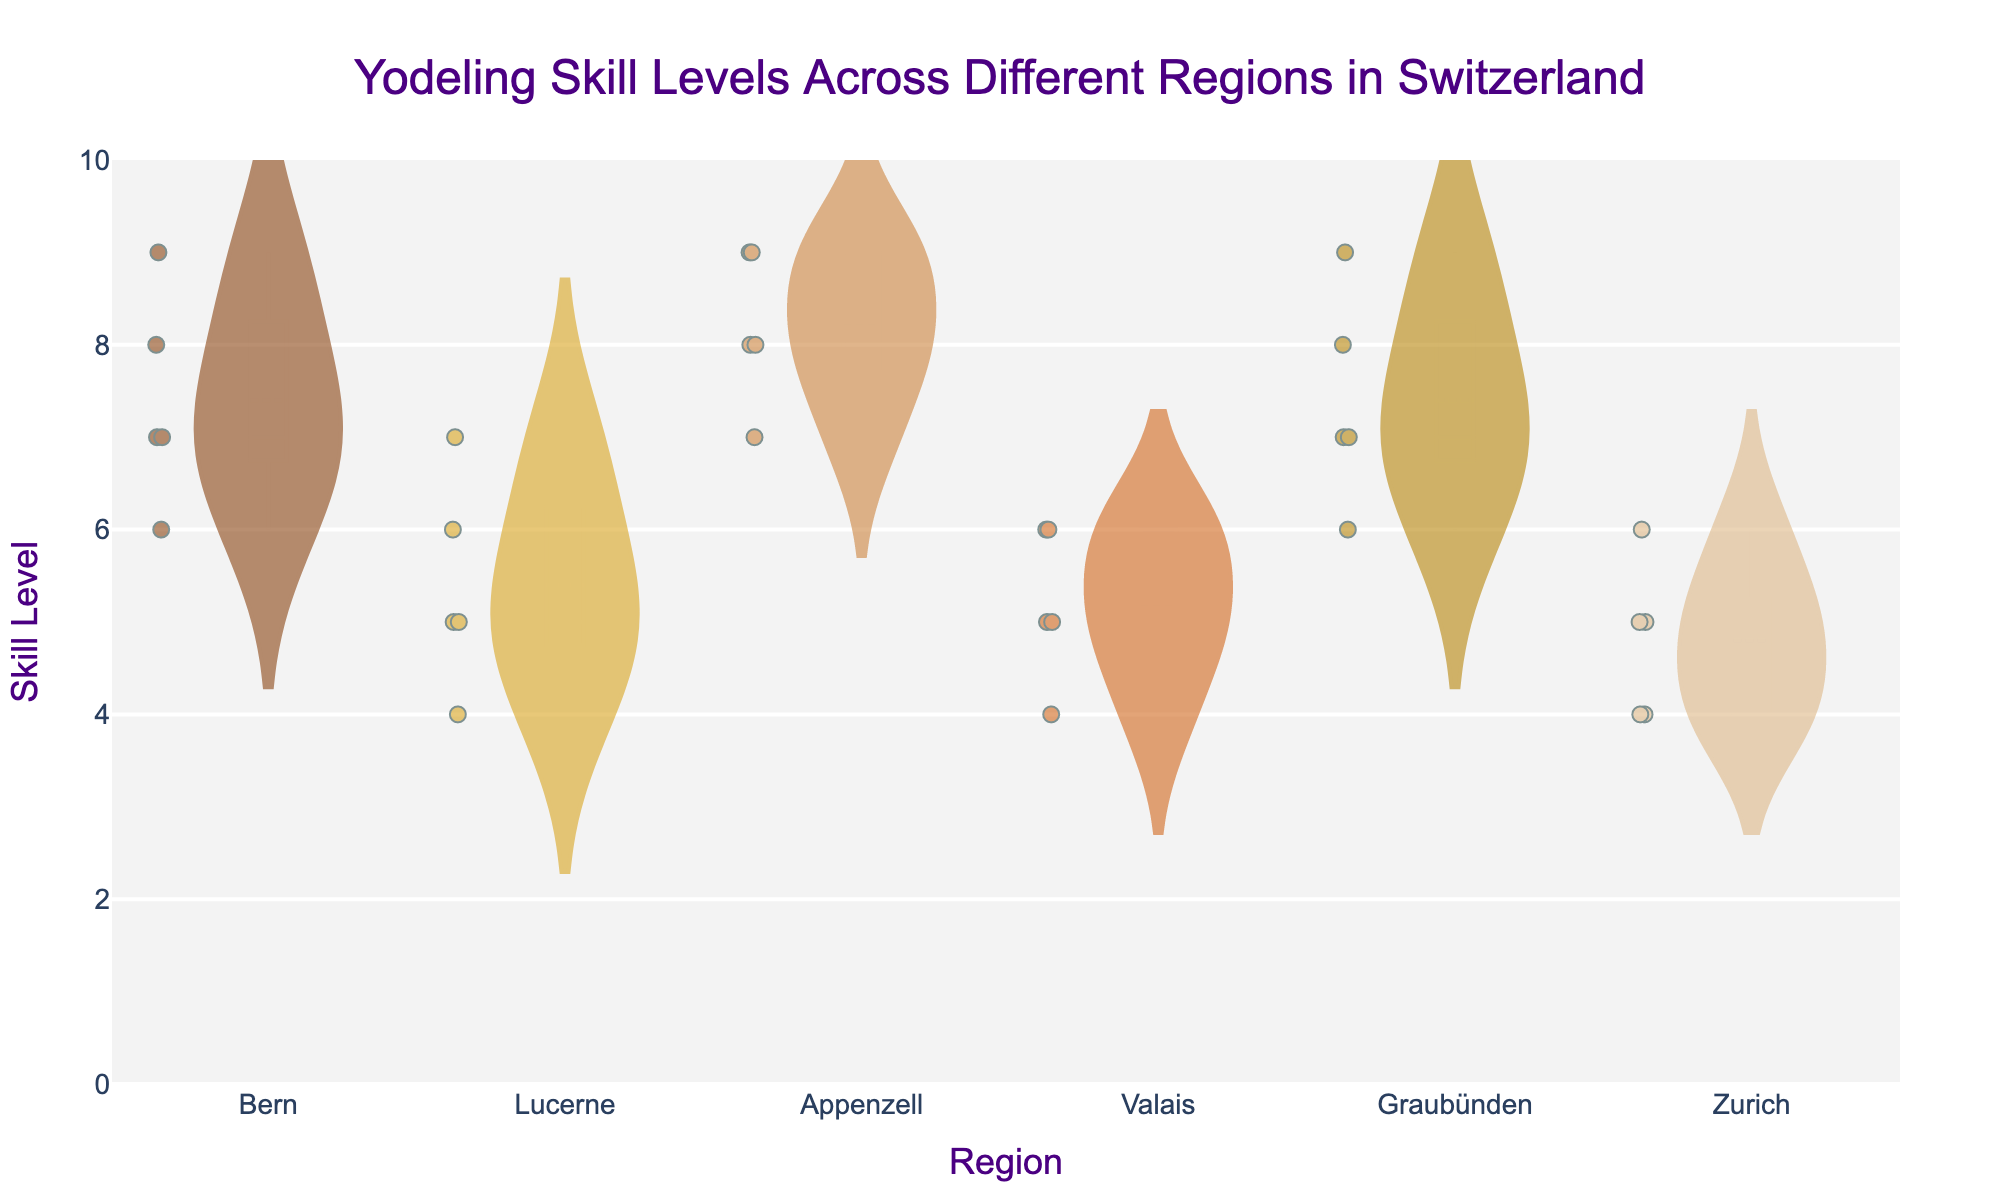What's the title of the figure? The title is usually located at the top of the figure. In this case, the visual information shows the title.
Answer: Yodeling Skill Levels Across Different Regions in Switzerland What is the range of the y-axis? The y-axis range can be determined by looking at the numerical values marked along the axis. Here it is specified from 0 to 10.
Answer: 0 to 10 How many regions are represented in the figure? By counting the unique groups displayed along the x-axis, which represent different regions, we can determine the number of regions. In this case, there are regions named Bern, Lucerne, Appenzell, Valais, Graubünden, and Zurich.
Answer: 6 Which region has the highest average yodeling skill level? To determine the highest average skill level, one must observe the mean lines on the violin plots for each region. The region with the topmost mean line has the highest average skill level. Here, Appenzell has the highest average.
Answer: Appenzell What skill levels do Graubünden yodelers typically fall within? By observing the body of the violin plot for Graubünden, we can determine the range of typical skill levels. Graubünden skill levels typically fall between 6 and 9.
Answer: 6 to 9 Which region has the most dispersed yodeling skill levels? To find the region with the most dispersed skill levels, observe the width and spread of the violin plot. The broader and more spread-out plot indicates more dispersion. Zurich appears to have a wide spread between 4 and 6.
Answer: Zurich What is the median skill level for yodelers in Valais? The median is indicated by the central line within the box part of the violin plot. For Valais, this line falls at 5.
Answer: 5 Which region's yodeling skill levels overlap the most with those in Bern? By comparing the overlap of the violin plots with Bern's range, we can see that Graubünden has similar skill levels, overlapping considerably around 6 to 8.
Answer: Graubünden What is the skill level of the best yodeler in Lucerne? The best yodeler in Lucerne is represented by the highest point within the Lucerne violin plot. This point is at a skill level of 7.
Answer: 7 How do the skill levels in Zurich compare to those in Bern? Comparing the width and placement of the violin plots for Zurich and Bern, Zurich has a lower average skill level, typically between 4 and 6, whereas Bern has higher skill levels, typically between 6 and 9.
Answer: Zurich has lower skill levels than Bern 